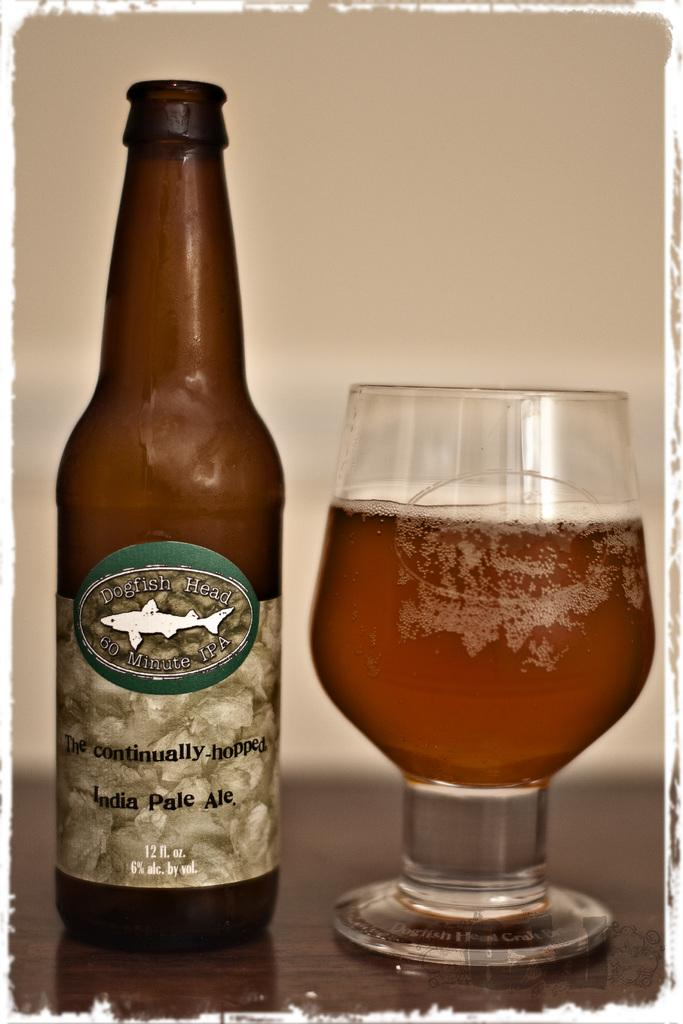Provide a one-sentence caption for the provided image. A glass of beer sits next to a bottle of IPA. 